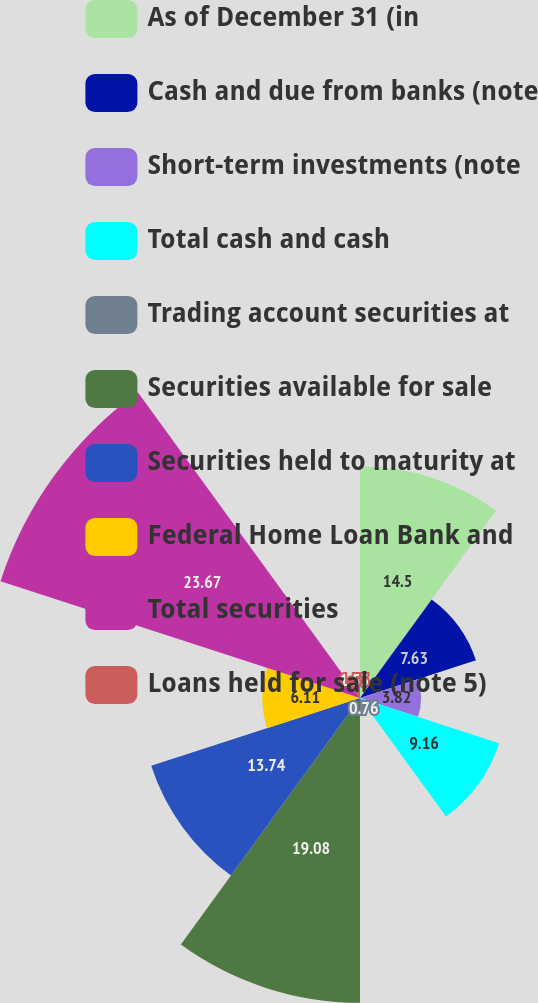Convert chart. <chart><loc_0><loc_0><loc_500><loc_500><pie_chart><fcel>As of December 31 (in<fcel>Cash and due from banks (note<fcel>Short-term investments (note<fcel>Total cash and cash<fcel>Trading account securities at<fcel>Securities available for sale<fcel>Securities held to maturity at<fcel>Federal Home Loan Bank and<fcel>Total securities<fcel>Loans held for sale (note 5)<nl><fcel>14.5%<fcel>7.63%<fcel>3.82%<fcel>9.16%<fcel>0.76%<fcel>19.08%<fcel>13.74%<fcel>6.11%<fcel>23.66%<fcel>1.53%<nl></chart> 